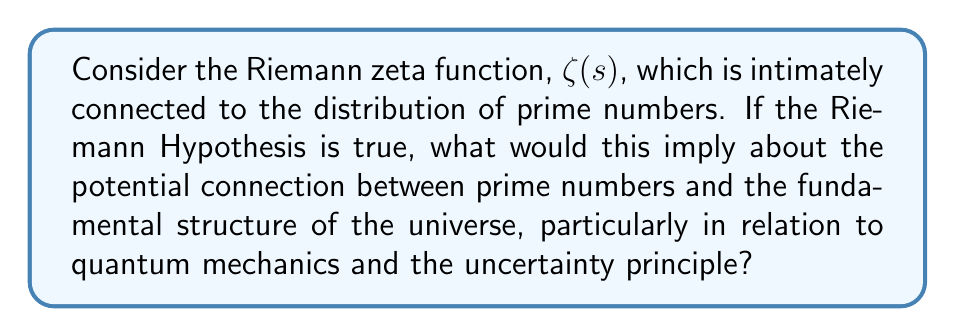Can you solve this math problem? 1. The Riemann zeta function is defined as:

   $$\zeta(s) = \sum_{n=1}^{\infty} \frac{1}{n^s}$$

   where $s$ is a complex number.

2. The Riemann Hypothesis states that all non-trivial zeros of $\zeta(s)$ have real part equal to $\frac{1}{2}$. This is equivalent to saying that all non-trivial zeros lie on the critical line $s = \frac{1}{2} + it$.

3. If the Riemann Hypothesis is true, it would imply a very specific and orderly distribution of prime numbers. This is because the zeros of $\zeta(s)$ are closely related to the distribution of primes through the explicit formula for the prime counting function.

4. In quantum mechanics, the uncertainty principle states that certain pairs of physical properties cannot be simultaneously known to arbitrary precision. Mathematically, this is expressed as:

   $$\Delta x \Delta p \geq \frac{\hbar}{2}$$

   where $\Delta x$ is the uncertainty in position, $\Delta p$ is the uncertainty in momentum, and $\hbar$ is the reduced Planck constant.

5. The orderly distribution of primes implied by the Riemann Hypothesis bears a striking resemblance to the quantum mechanical concept of energy levels in atoms. Just as electron energy levels are quantized, the gaps between primes follow a specific pattern.

6. Moreover, the critical line in the Riemann Hypothesis ($s = \frac{1}{2} + it$) is reminiscent of the wave function in quantum mechanics, which describes the quantum state of a system and contains complex numbers.

7. The potential connection lies in the idea that both prime numbers and quantum mechanics deal with discrete, fundamental units (primes and quanta) while also involving continuous, wave-like properties (the critical line and wave functions).

8. This suggests that the distribution of primes might be governed by principles similar to those in quantum mechanics, potentially pointing to a deeper, underlying structure in the universe that manifests in both mathematics and physics.

9. If true, this connection could imply that the uncertainty and probabilistic nature inherent in quantum mechanics might also be present in the world of prime numbers, challenging our notions of determinism even in pure mathematics.
Answer: The Riemann Hypothesis implies an orderly distribution of primes, potentially reflecting quantum mechanical principles in mathematics and suggesting a fundamental structure linking discrete and continuous aspects of reality. 